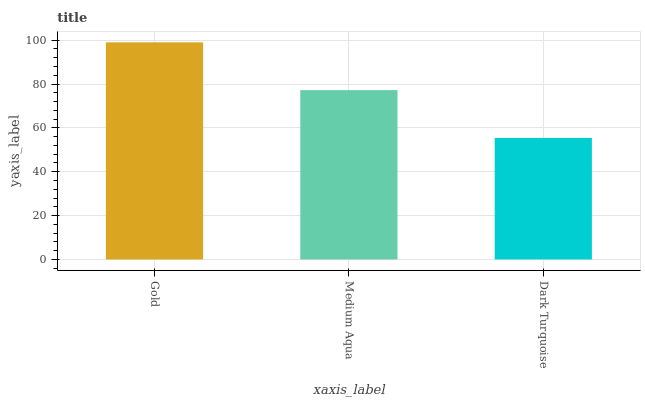Is Dark Turquoise the minimum?
Answer yes or no. Yes. Is Gold the maximum?
Answer yes or no. Yes. Is Medium Aqua the minimum?
Answer yes or no. No. Is Medium Aqua the maximum?
Answer yes or no. No. Is Gold greater than Medium Aqua?
Answer yes or no. Yes. Is Medium Aqua less than Gold?
Answer yes or no. Yes. Is Medium Aqua greater than Gold?
Answer yes or no. No. Is Gold less than Medium Aqua?
Answer yes or no. No. Is Medium Aqua the high median?
Answer yes or no. Yes. Is Medium Aqua the low median?
Answer yes or no. Yes. Is Gold the high median?
Answer yes or no. No. Is Dark Turquoise the low median?
Answer yes or no. No. 